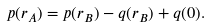Convert formula to latex. <formula><loc_0><loc_0><loc_500><loc_500>p ( r _ { A } ) = p ( r _ { B } ) - q ( r _ { B } ) + q ( 0 ) .</formula> 